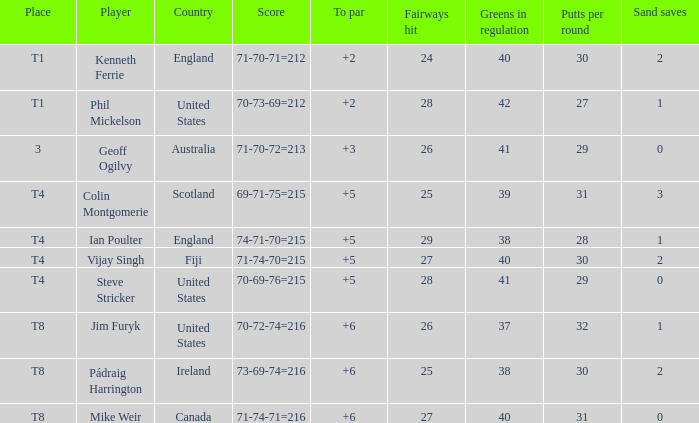What score to par did Mike Weir have? 6.0. 